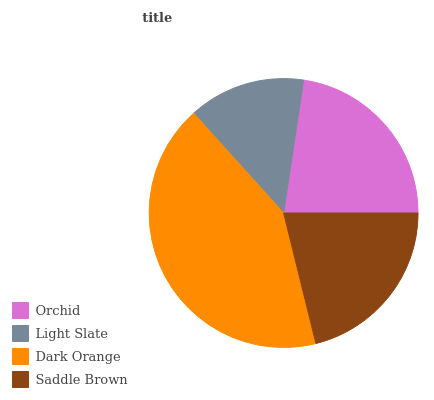Is Light Slate the minimum?
Answer yes or no. Yes. Is Dark Orange the maximum?
Answer yes or no. Yes. Is Dark Orange the minimum?
Answer yes or no. No. Is Light Slate the maximum?
Answer yes or no. No. Is Dark Orange greater than Light Slate?
Answer yes or no. Yes. Is Light Slate less than Dark Orange?
Answer yes or no. Yes. Is Light Slate greater than Dark Orange?
Answer yes or no. No. Is Dark Orange less than Light Slate?
Answer yes or no. No. Is Orchid the high median?
Answer yes or no. Yes. Is Saddle Brown the low median?
Answer yes or no. Yes. Is Light Slate the high median?
Answer yes or no. No. Is Dark Orange the low median?
Answer yes or no. No. 